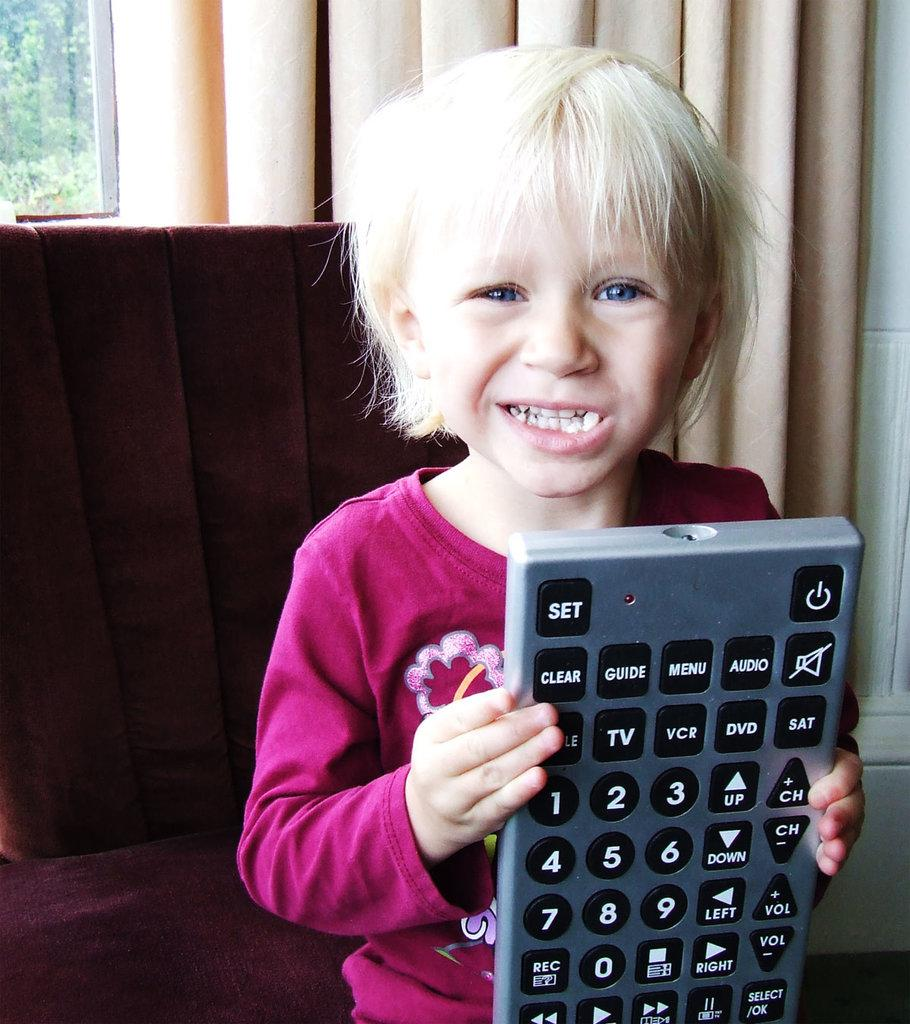<image>
Provide a brief description of the given image. blonde child in pinkish red top holding giant tv remote with buttons visible such as clear, guide, audio, vcr, dvd, etc. 